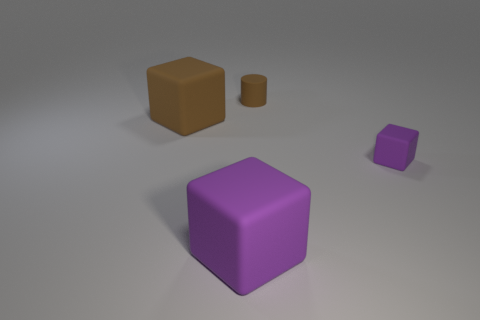Add 4 large purple rubber objects. How many objects exist? 8 Subtract all blocks. How many objects are left? 1 Subtract 0 purple cylinders. How many objects are left? 4 Subtract all tiny purple cubes. Subtract all big brown objects. How many objects are left? 2 Add 1 purple objects. How many purple objects are left? 3 Add 2 large brown matte things. How many large brown matte things exist? 3 